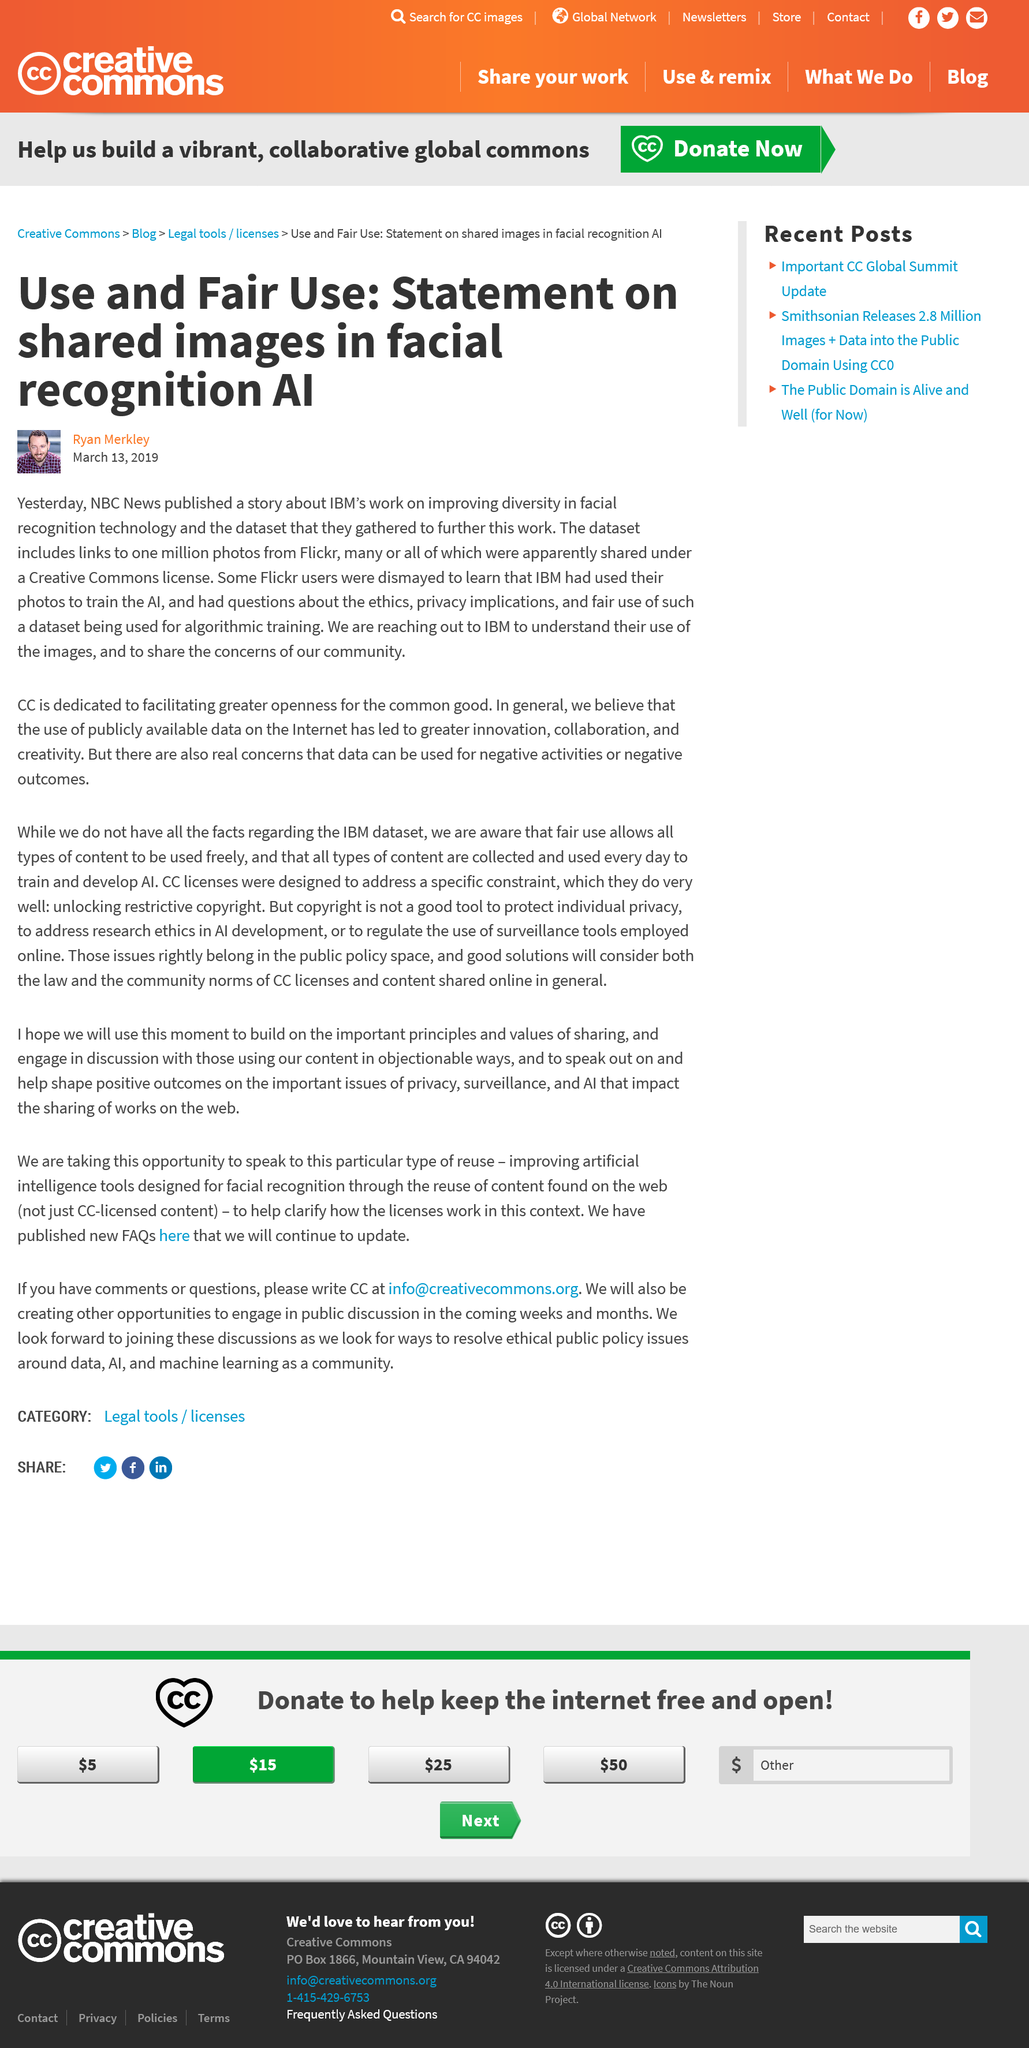Draw attention to some important aspects in this diagram. On March 12, 2019, NBC News published a story about IBM's work on improving diversity in facial recognition technology. Creative Commons reached out to IBM to inquire about their use of Flickr images in enhancing their facial recognition technology. IBM's facial recognition technology was improved using images obtained from Flickr, which were creative commons licensed. 